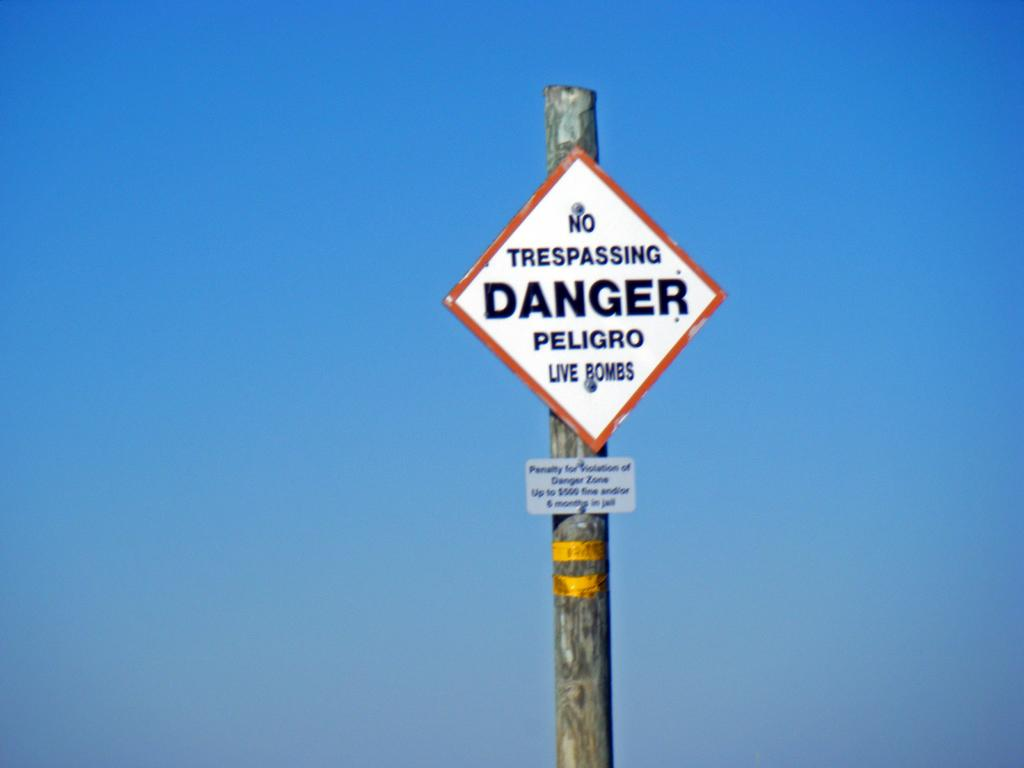Provide a one-sentence caption for the provided image. a pole that states no trespassing danger in a diamond shape. 